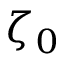<formula> <loc_0><loc_0><loc_500><loc_500>\zeta _ { 0 }</formula> 